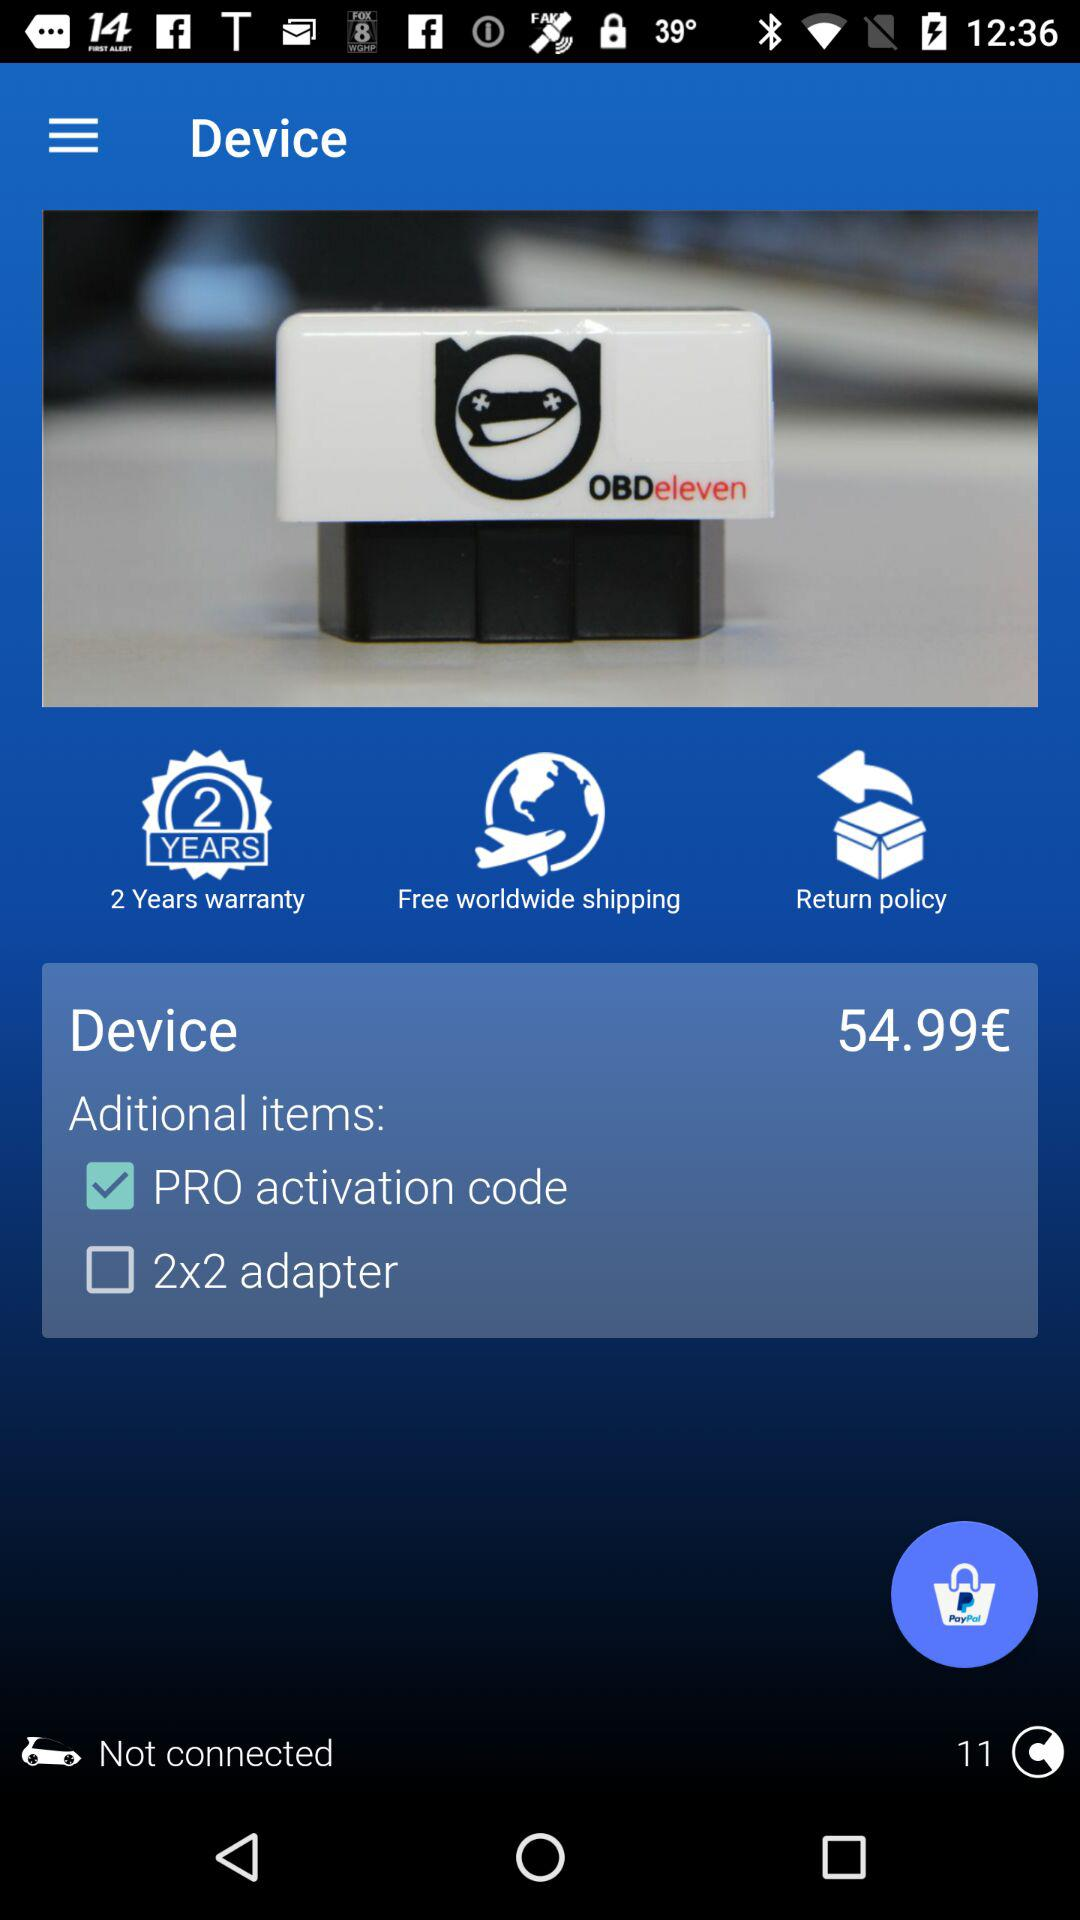Which additional item is selected with the device? The selected additional item is "PRO activation code". 